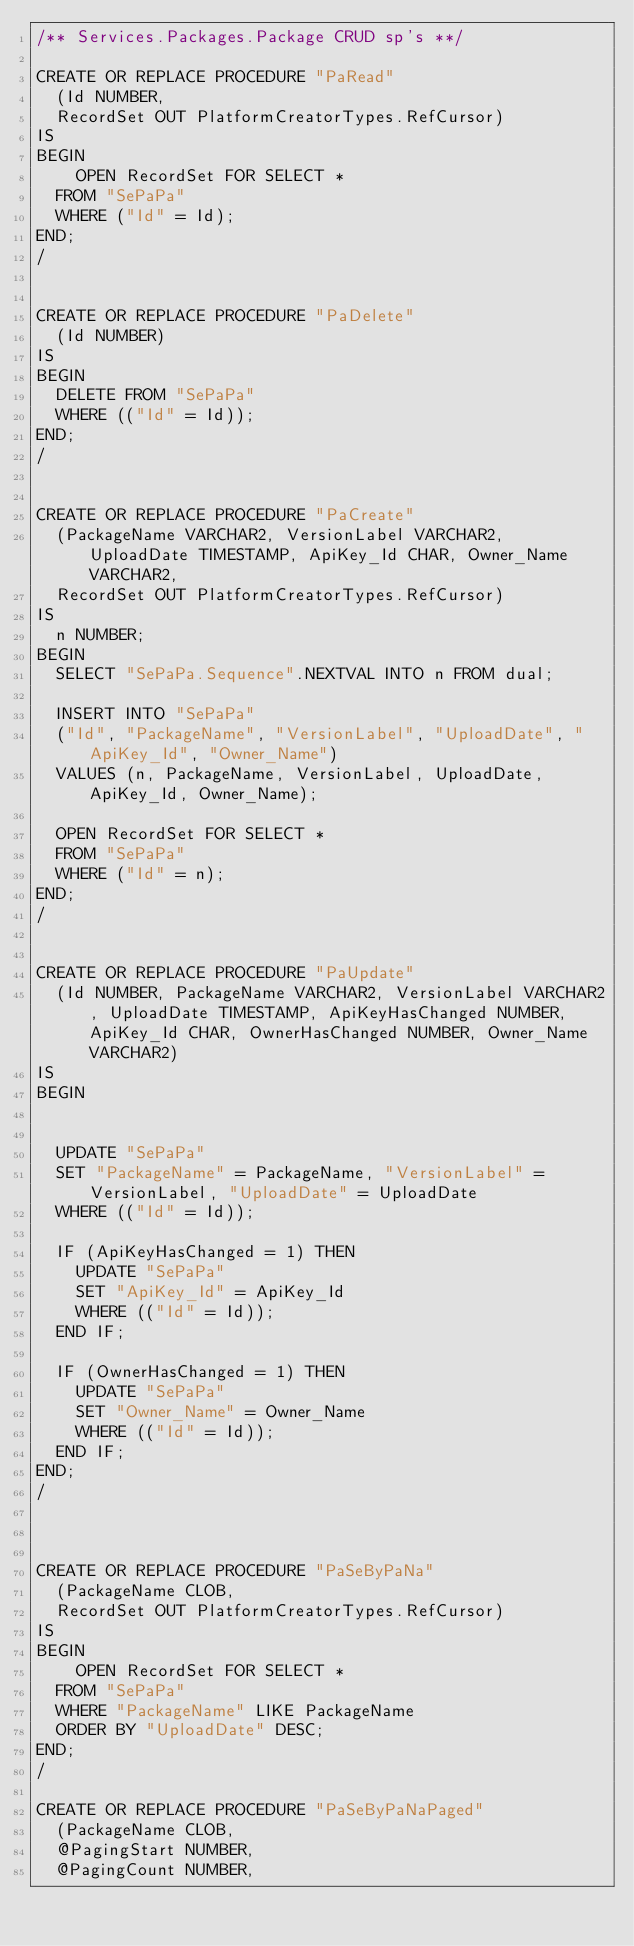Convert code to text. <code><loc_0><loc_0><loc_500><loc_500><_SQL_>/** Services.Packages.Package CRUD sp's **/

CREATE OR REPLACE PROCEDURE "PaRead"
	(Id NUMBER,
	RecordSet OUT PlatformCreatorTypes.RefCursor)
IS
BEGIN
    OPEN RecordSet FOR SELECT *
	FROM "SePaPa"
	WHERE ("Id" = Id);
END;
/


CREATE OR REPLACE PROCEDURE "PaDelete"
	(Id NUMBER)
IS
BEGIN
	DELETE FROM "SePaPa"
	WHERE (("Id" = Id));
END;
/


CREATE OR REPLACE PROCEDURE "PaCreate"
	(PackageName VARCHAR2, VersionLabel VARCHAR2, UploadDate TIMESTAMP, ApiKey_Id CHAR, Owner_Name VARCHAR2,
	RecordSet OUT PlatformCreatorTypes.RefCursor)
IS
	n NUMBER;
BEGIN
	SELECT "SePaPa.Sequence".NEXTVAL INTO n FROM dual;
	
	INSERT INTO "SePaPa"
	("Id", "PackageName", "VersionLabel", "UploadDate", "ApiKey_Id", "Owner_Name")
	VALUES (n, PackageName, VersionLabel, UploadDate, ApiKey_Id, Owner_Name);
	
	OPEN RecordSet FOR SELECT *
	FROM "SePaPa"
	WHERE ("Id" = n);
END;
/


CREATE OR REPLACE PROCEDURE "PaUpdate"
	(Id NUMBER, PackageName VARCHAR2, VersionLabel VARCHAR2, UploadDate TIMESTAMP, ApiKeyHasChanged NUMBER, ApiKey_Id CHAR, OwnerHasChanged NUMBER, Owner_Name VARCHAR2)
IS
BEGIN
	
	
	UPDATE "SePaPa"
	SET "PackageName" = PackageName, "VersionLabel" = VersionLabel, "UploadDate" = UploadDate
	WHERE (("Id" = Id));
	
	IF (ApiKeyHasChanged = 1) THEN
		UPDATE "SePaPa"
		SET "ApiKey_Id" = ApiKey_Id
		WHERE (("Id" = Id));
	END IF;
	
	IF (OwnerHasChanged = 1) THEN
		UPDATE "SePaPa"
		SET "Owner_Name" = Owner_Name
		WHERE (("Id" = Id));
	END IF;
END;
/



CREATE OR REPLACE PROCEDURE "PaSeByPaNa"
	(PackageName CLOB,
	RecordSet OUT PlatformCreatorTypes.RefCursor)
IS
BEGIN
    OPEN RecordSet FOR SELECT *
	FROM "SePaPa"
	WHERE "PackageName" LIKE PackageName 
	ORDER BY "UploadDate" DESC;
END;
/

CREATE OR REPLACE PROCEDURE "PaSeByPaNaPaged"
	(PackageName CLOB,
	@PagingStart NUMBER,
	@PagingCount NUMBER,</code> 